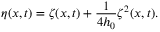Convert formula to latex. <formula><loc_0><loc_0><loc_500><loc_500>\eta ( x , t ) = \zeta ( x , t ) + \frac { 1 } { 4 h _ { 0 } } \zeta ^ { 2 } ( x , t ) .</formula> 